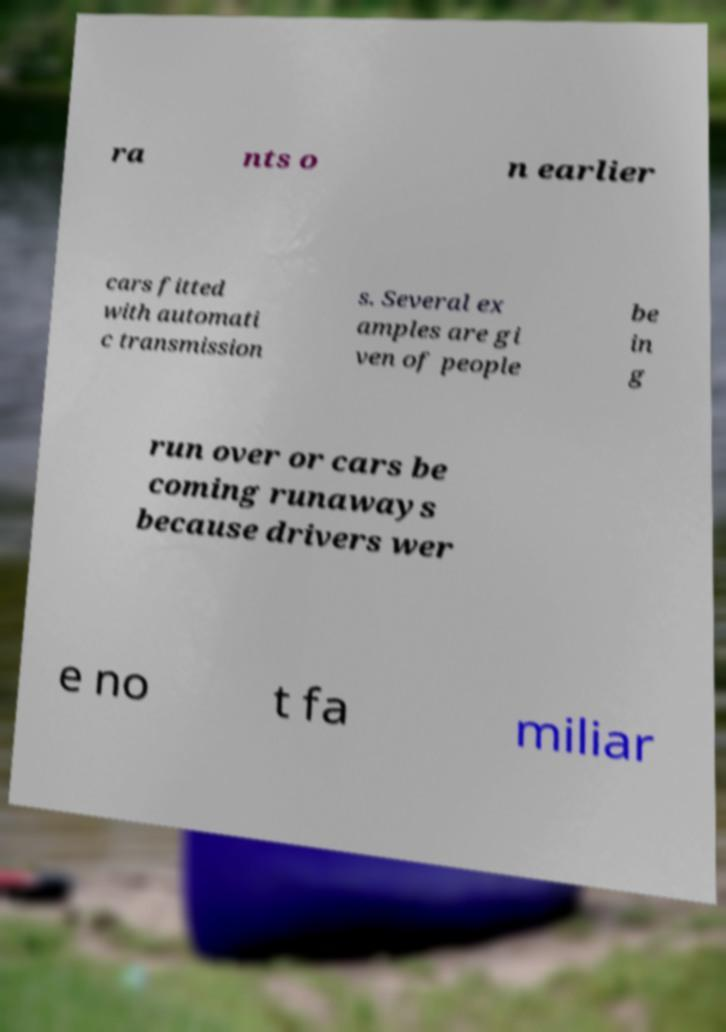Please read and relay the text visible in this image. What does it say? ra nts o n earlier cars fitted with automati c transmission s. Several ex amples are gi ven of people be in g run over or cars be coming runaways because drivers wer e no t fa miliar 